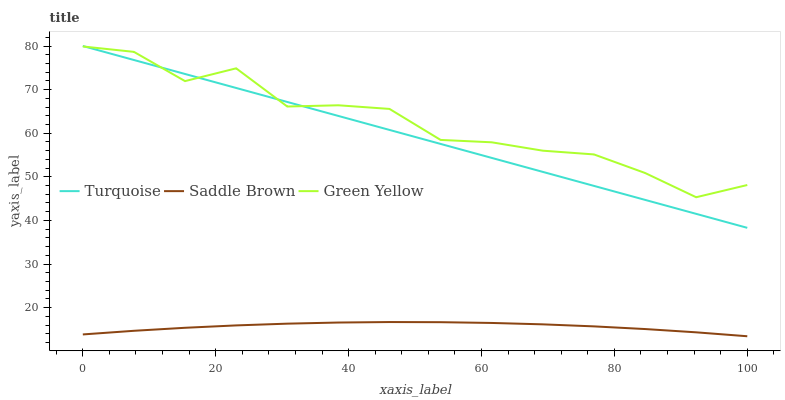Does Saddle Brown have the minimum area under the curve?
Answer yes or no. Yes. Does Green Yellow have the maximum area under the curve?
Answer yes or no. Yes. Does Green Yellow have the minimum area under the curve?
Answer yes or no. No. Does Saddle Brown have the maximum area under the curve?
Answer yes or no. No. Is Turquoise the smoothest?
Answer yes or no. Yes. Is Green Yellow the roughest?
Answer yes or no. Yes. Is Saddle Brown the smoothest?
Answer yes or no. No. Is Saddle Brown the roughest?
Answer yes or no. No. Does Saddle Brown have the lowest value?
Answer yes or no. Yes. Does Green Yellow have the lowest value?
Answer yes or no. No. Does Turquoise have the highest value?
Answer yes or no. Yes. Does Green Yellow have the highest value?
Answer yes or no. No. Is Saddle Brown less than Green Yellow?
Answer yes or no. Yes. Is Turquoise greater than Saddle Brown?
Answer yes or no. Yes. Does Green Yellow intersect Turquoise?
Answer yes or no. Yes. Is Green Yellow less than Turquoise?
Answer yes or no. No. Is Green Yellow greater than Turquoise?
Answer yes or no. No. Does Saddle Brown intersect Green Yellow?
Answer yes or no. No. 